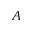Convert formula to latex. <formula><loc_0><loc_0><loc_500><loc_500>A</formula> 